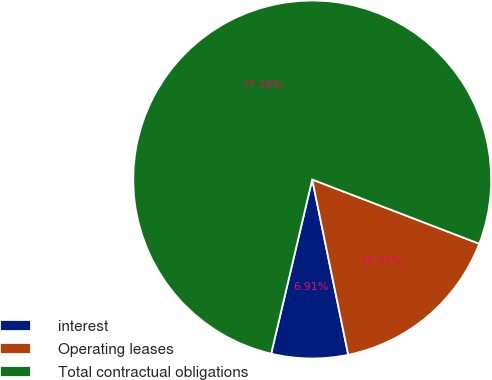<chart> <loc_0><loc_0><loc_500><loc_500><pie_chart><fcel>interest<fcel>Operating leases<fcel>Total contractual obligations<nl><fcel>6.91%<fcel>15.93%<fcel>77.16%<nl></chart> 